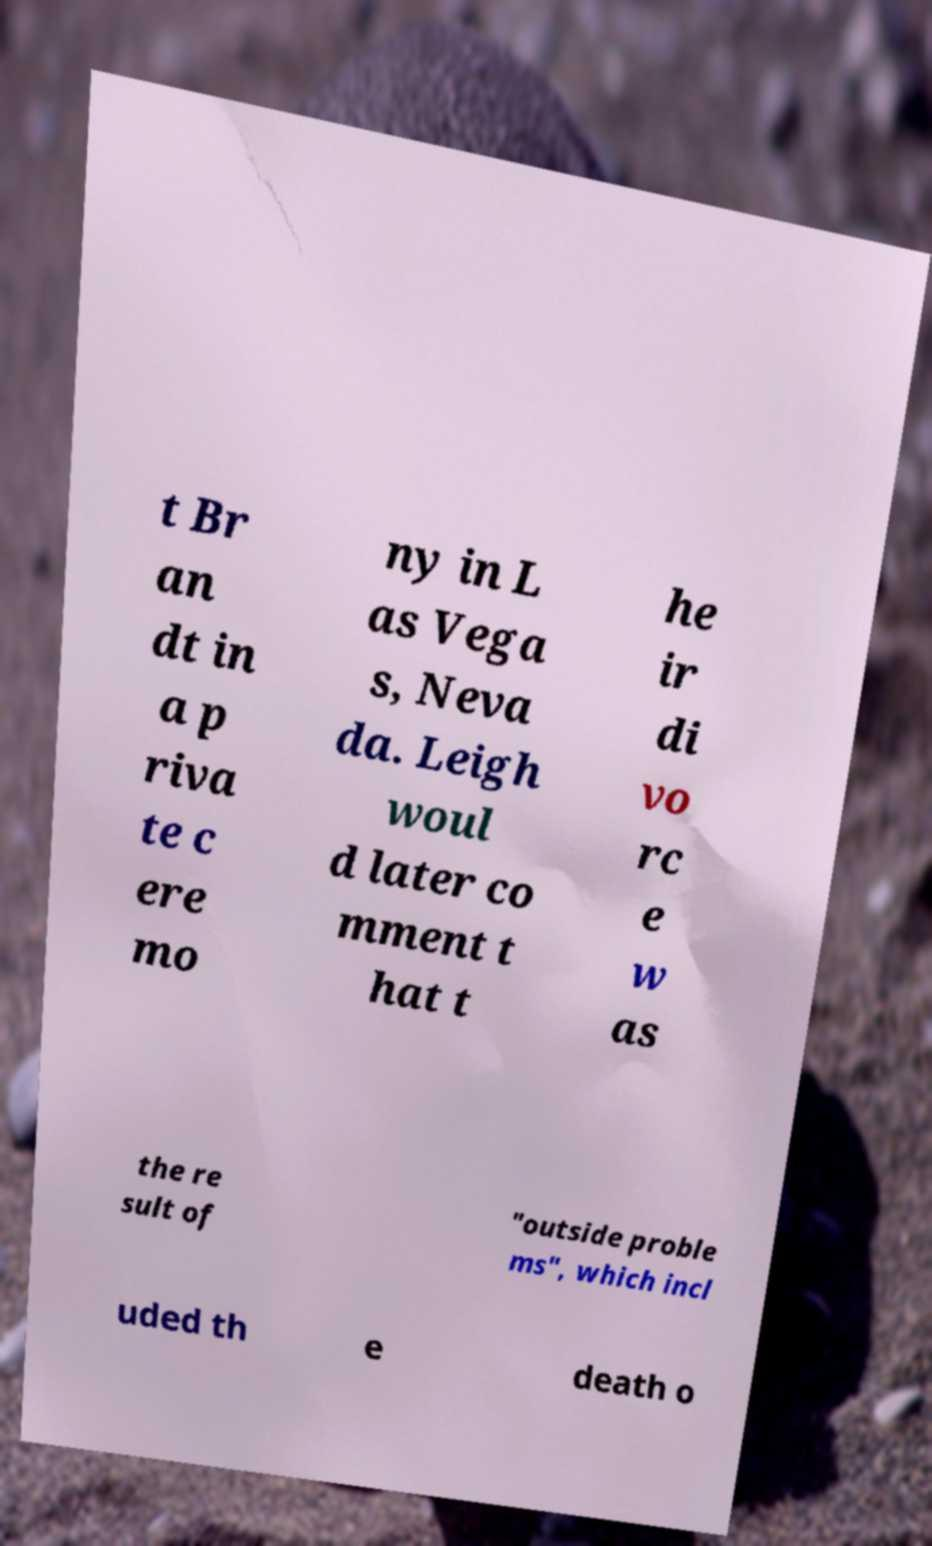I need the written content from this picture converted into text. Can you do that? t Br an dt in a p riva te c ere mo ny in L as Vega s, Neva da. Leigh woul d later co mment t hat t he ir di vo rc e w as the re sult of "outside proble ms", which incl uded th e death o 